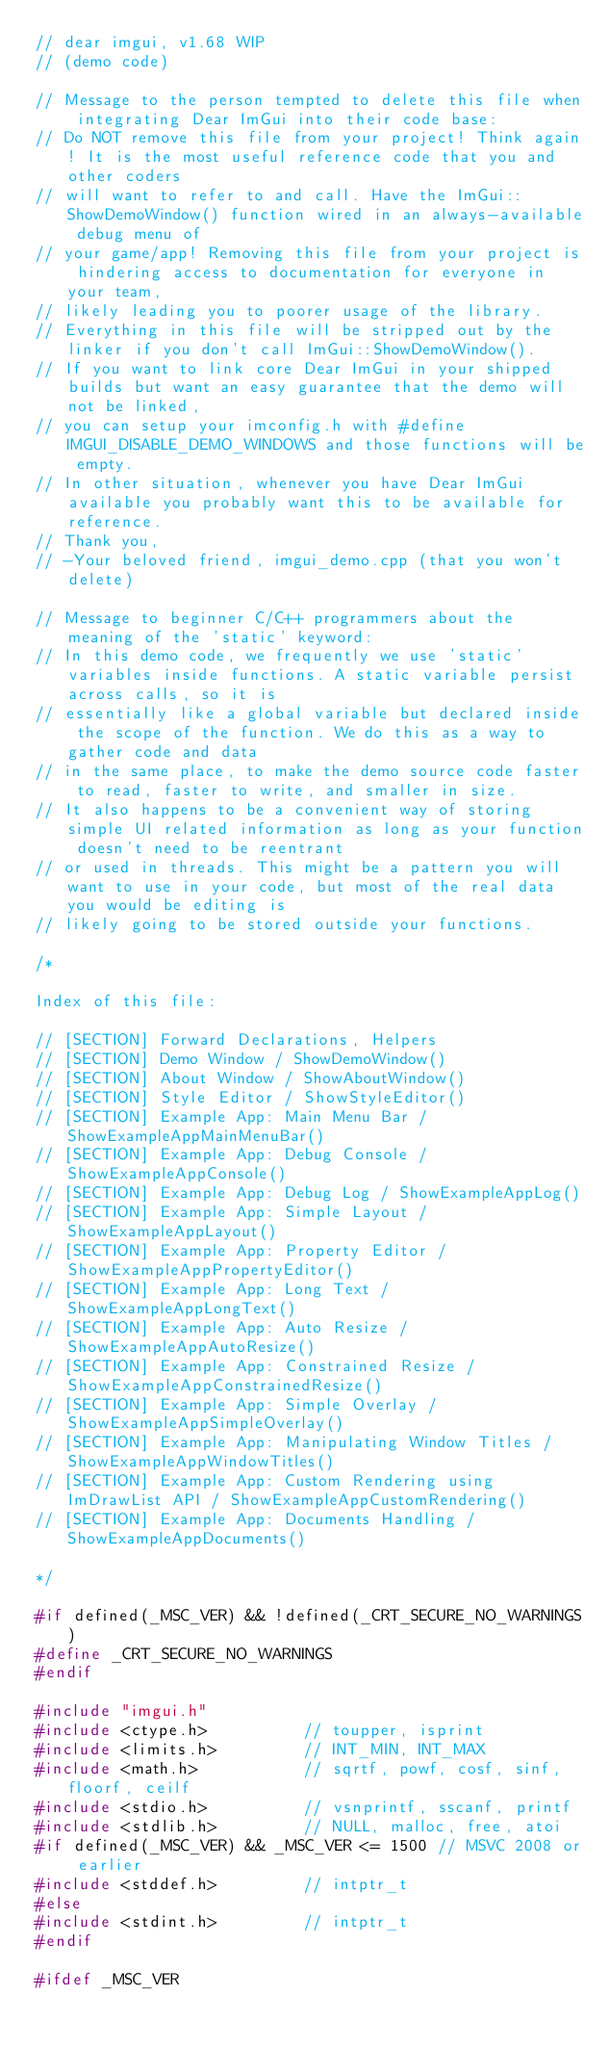Convert code to text. <code><loc_0><loc_0><loc_500><loc_500><_C++_>// dear imgui, v1.68 WIP
// (demo code)

// Message to the person tempted to delete this file when integrating Dear ImGui into their code base:
// Do NOT remove this file from your project! Think again! It is the most useful reference code that you and other coders
// will want to refer to and call. Have the ImGui::ShowDemoWindow() function wired in an always-available debug menu of
// your game/app! Removing this file from your project is hindering access to documentation for everyone in your team,
// likely leading you to poorer usage of the library.
// Everything in this file will be stripped out by the linker if you don't call ImGui::ShowDemoWindow().
// If you want to link core Dear ImGui in your shipped builds but want an easy guarantee that the demo will not be linked,
// you can setup your imconfig.h with #define IMGUI_DISABLE_DEMO_WINDOWS and those functions will be empty.
// In other situation, whenever you have Dear ImGui available you probably want this to be available for reference.
// Thank you,
// -Your beloved friend, imgui_demo.cpp (that you won't delete)

// Message to beginner C/C++ programmers about the meaning of the 'static' keyword:
// In this demo code, we frequently we use 'static' variables inside functions. A static variable persist across calls, so it is
// essentially like a global variable but declared inside the scope of the function. We do this as a way to gather code and data
// in the same place, to make the demo source code faster to read, faster to write, and smaller in size.
// It also happens to be a convenient way of storing simple UI related information as long as your function doesn't need to be reentrant
// or used in threads. This might be a pattern you will want to use in your code, but most of the real data you would be editing is
// likely going to be stored outside your functions.

/*

Index of this file:

// [SECTION] Forward Declarations, Helpers
// [SECTION] Demo Window / ShowDemoWindow()
// [SECTION] About Window / ShowAboutWindow()
// [SECTION] Style Editor / ShowStyleEditor()
// [SECTION] Example App: Main Menu Bar / ShowExampleAppMainMenuBar()
// [SECTION] Example App: Debug Console / ShowExampleAppConsole()
// [SECTION] Example App: Debug Log / ShowExampleAppLog()
// [SECTION] Example App: Simple Layout / ShowExampleAppLayout()
// [SECTION] Example App: Property Editor / ShowExampleAppPropertyEditor()
// [SECTION] Example App: Long Text / ShowExampleAppLongText()
// [SECTION] Example App: Auto Resize / ShowExampleAppAutoResize()
// [SECTION] Example App: Constrained Resize / ShowExampleAppConstrainedResize()
// [SECTION] Example App: Simple Overlay / ShowExampleAppSimpleOverlay()
// [SECTION] Example App: Manipulating Window Titles / ShowExampleAppWindowTitles()
// [SECTION] Example App: Custom Rendering using ImDrawList API / ShowExampleAppCustomRendering()
// [SECTION] Example App: Documents Handling / ShowExampleAppDocuments()

*/

#if defined(_MSC_VER) && !defined(_CRT_SECURE_NO_WARNINGS)
#define _CRT_SECURE_NO_WARNINGS
#endif

#include "imgui.h"
#include <ctype.h>          // toupper, isprint
#include <limits.h>         // INT_MIN, INT_MAX
#include <math.h>           // sqrtf, powf, cosf, sinf, floorf, ceilf
#include <stdio.h>          // vsnprintf, sscanf, printf
#include <stdlib.h>         // NULL, malloc, free, atoi
#if defined(_MSC_VER) && _MSC_VER <= 1500 // MSVC 2008 or earlier
#include <stddef.h>         // intptr_t
#else
#include <stdint.h>         // intptr_t
#endif

#ifdef _MSC_VER</code> 